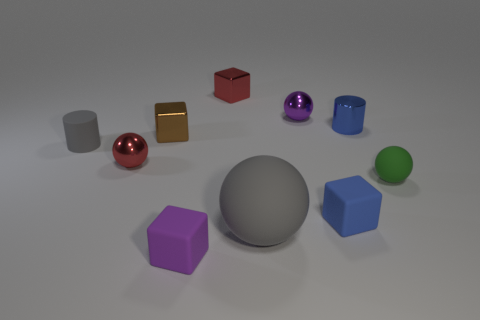Can you describe the shapes present and their associated colors? Certainly, the image contains a variety of geometric shapes. We have a gray rubber ball, a red cube, a gold cube, a purple sphere, a blue cube, a silver cylinder, a green sphere, and a purple cube. 